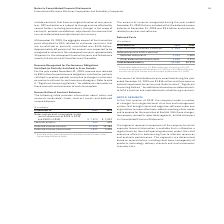According to International Business Machines's financial document, What is the current and noncurrent total deferred costs for 2019? $1,896 million was current and $2,472 million was noncurrent at December 31, 2019. The document states: "(1) Of the total deferred costs, $1,896 million was current and $2,472 million was noncurrent at December 31, 2019 and $2,300 million was current and ..." Also, What is the current and noncurrent total deferred costs for 2018? $2,300 million was current and $2,676 million was noncurrent at December 31, 2018.. The document states: "72 million was noncurrent at December 31, 2019 and $2,300 million was current and $2,676 million was noncurrent at December 31, 2018...." Also, What is the total deferred costs amortized during 2019? According to the financial document, $3,836 million. The relevant text states: "rtized during the year ended December 31, 2019 was $3,836 million and there were no material impairment losses incurred. Refer to note A, “Significant Accounting Poli..." Also, can you calculate: What is the increase/ (decrease) in Capitalized costs to obtain a contract from 2018 to 2019 Based on the calculation: 609-717, the result is -108 (in millions). This is based on the information: "Capitalized costs to obtain a contract $ 609 $ 717 Capitalized costs to obtain a contract $ 609 $ 717..." The key data points involved are: 609, 717. Also, can you calculate: What is the average of Capitalized costs to obtain a contract? To answer this question, I need to perform calculations using the financial data. The calculation is: (609+717) / 2, which equals 663 (in millions). This is based on the information: "Capitalized costs to obtain a contract $ 609 $ 717 Capitalized costs to obtain a contract $ 609 $ 717..." The key data points involved are: 609, 717. Also, can you calculate: What is the average of Deferred setup costs? To answer this question, I need to perform calculations using the financial data. The calculation is: (1,939 +2,085) / 2, which equals 2012 (in millions). This is based on the information: "Deferred setup costs 1,939 2,085 Deferred setup costs 1,939 2,085..." The key data points involved are: 1,939, 2,085. 